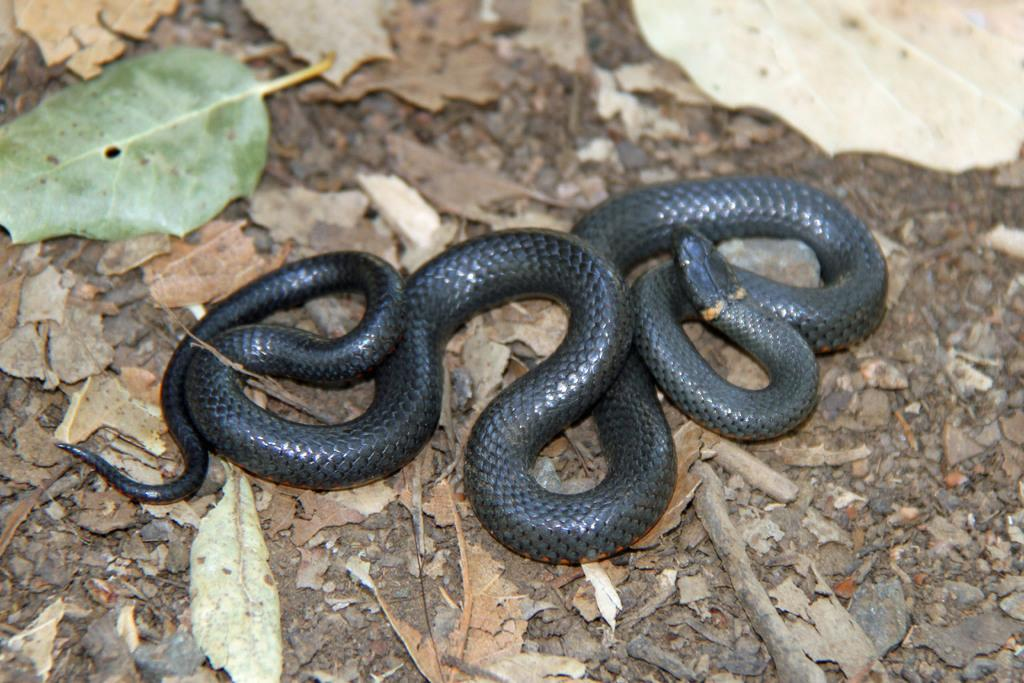What type of animal is in the image? There is a black color snake in the image. Where is the snake located? The snake is on the ground. What else can be seen on the ground in the image? Dry leaves are present in the image. Can you hear the snake growing in the image? There is no sound or indication of growth in the image; it is a still photograph. 